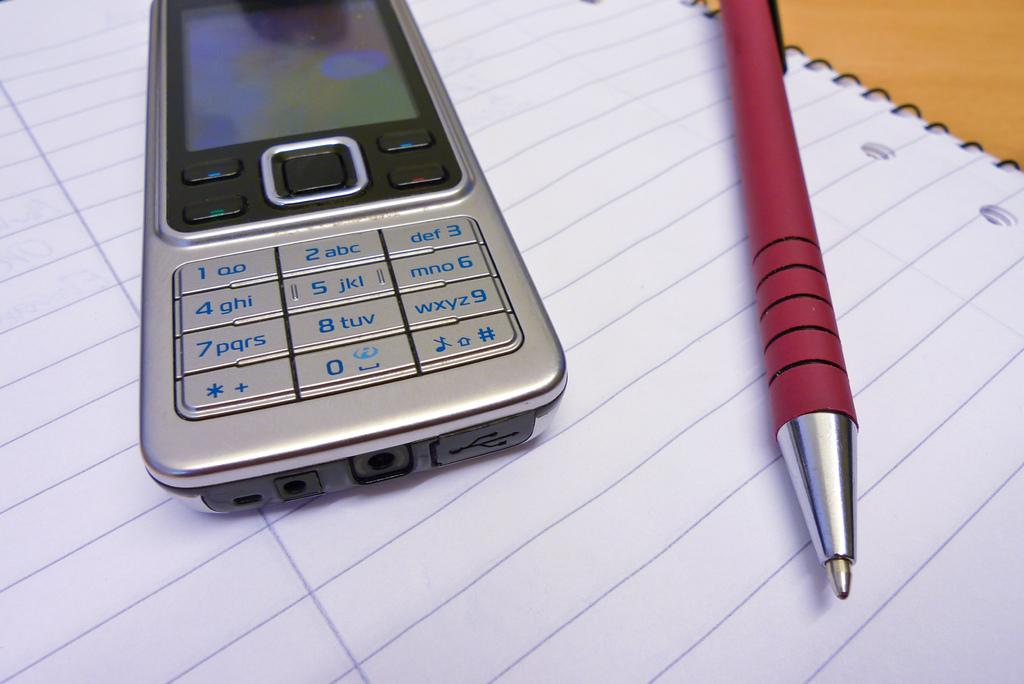What is the main object in the image? There is a mobile in the image. What other objects can be seen in the image? There is a pen and a book in the image. How are the mobile and pen positioned in relation to the book? The mobile and pen are placed on the book. What type of property is visible in the image? There is no property visible in the image; it only features a mobile, pen, and book. Can you describe the home in the image? There is no home present in the image. 